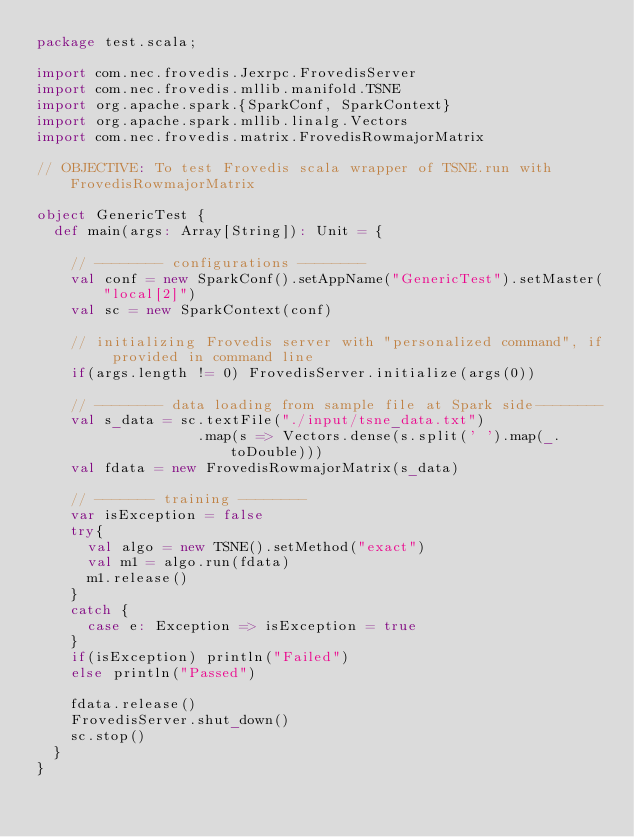Convert code to text. <code><loc_0><loc_0><loc_500><loc_500><_Scala_>package test.scala;

import com.nec.frovedis.Jexrpc.FrovedisServer
import com.nec.frovedis.mllib.manifold.TSNE
import org.apache.spark.{SparkConf, SparkContext}
import org.apache.spark.mllib.linalg.Vectors
import com.nec.frovedis.matrix.FrovedisRowmajorMatrix

// OBJECTIVE: To test Frovedis scala wrapper of TSNE.run with FrovedisRowmajorMatrix

object GenericTest {
  def main(args: Array[String]): Unit = {

    // -------- configurations --------
    val conf = new SparkConf().setAppName("GenericTest").setMaster("local[2]")
    val sc = new SparkContext(conf)

    // initializing Frovedis server with "personalized command", if provided in command line
    if(args.length != 0) FrovedisServer.initialize(args(0))

    // -------- data loading from sample file at Spark side--------
    val s_data = sc.textFile("./input/tsne_data.txt")
                   .map(s => Vectors.dense(s.split(' ').map(_.toDouble)))
    val fdata = new FrovedisRowmajorMatrix(s_data)

    // ------- training --------
    var isException = false
    try{
      val algo = new TSNE().setMethod("exact")
      val m1 = algo.run(fdata)
      m1.release()
    }
    catch {
      case e: Exception => isException = true
    }
    if(isException) println("Failed")
    else println("Passed")

    fdata.release()
    FrovedisServer.shut_down()
    sc.stop()
  }
}
</code> 